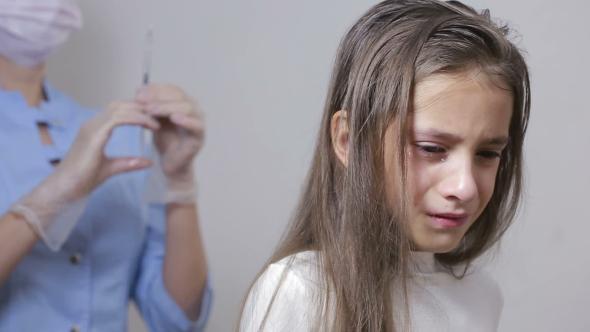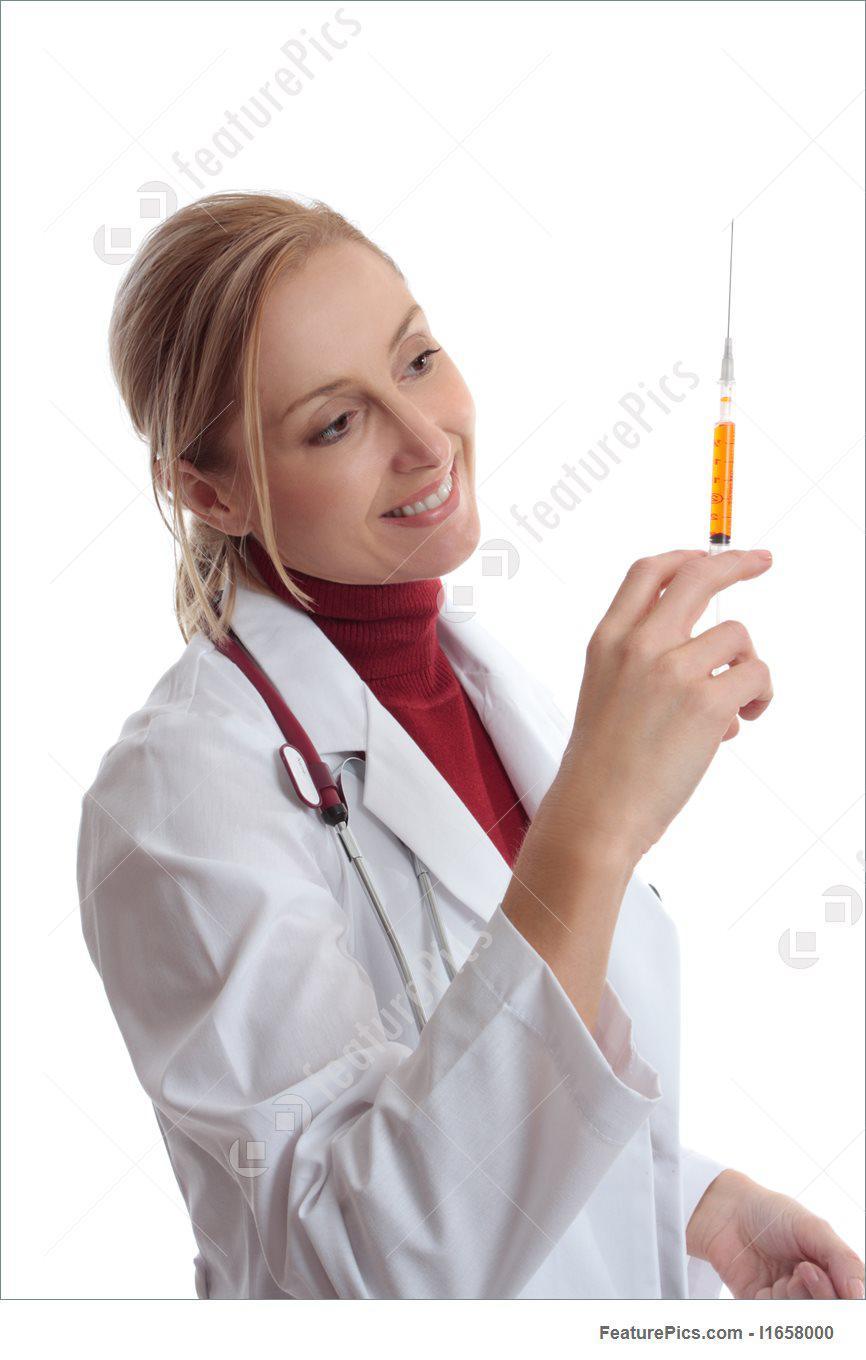The first image is the image on the left, the second image is the image on the right. For the images displayed, is the sentence "The right image shows a woman in a white lab coat holding up a hypodermic needle and looking at it." factually correct? Answer yes or no. Yes. The first image is the image on the left, the second image is the image on the right. Assess this claim about the two images: "The left and right image contains two doctors and one patient.". Correct or not? Answer yes or no. Yes. 